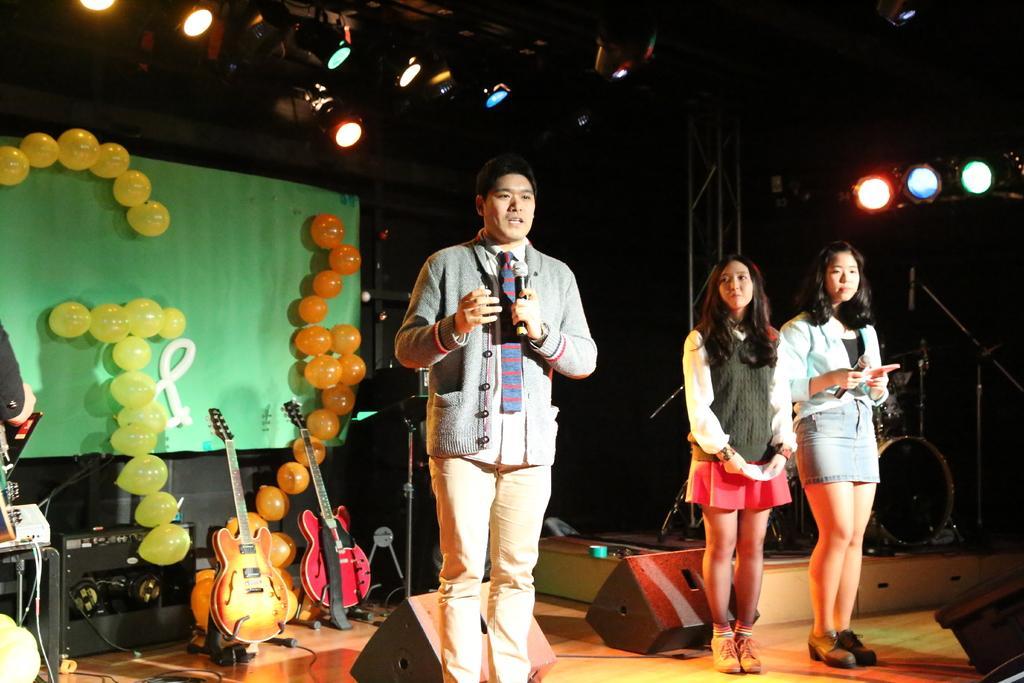Please provide a concise description of this image. In the center of the image there is a person who is standing on a stage and he is speaking something on a mic. On the right there are two women standing beside the speakers. This woman looking to a man. On the top right there is a light. On left there is a banner which is attached by balloons. There are yellow balloon and orange balloon. Here it's a guitar. On bottom left corner there is a musical instrument. 